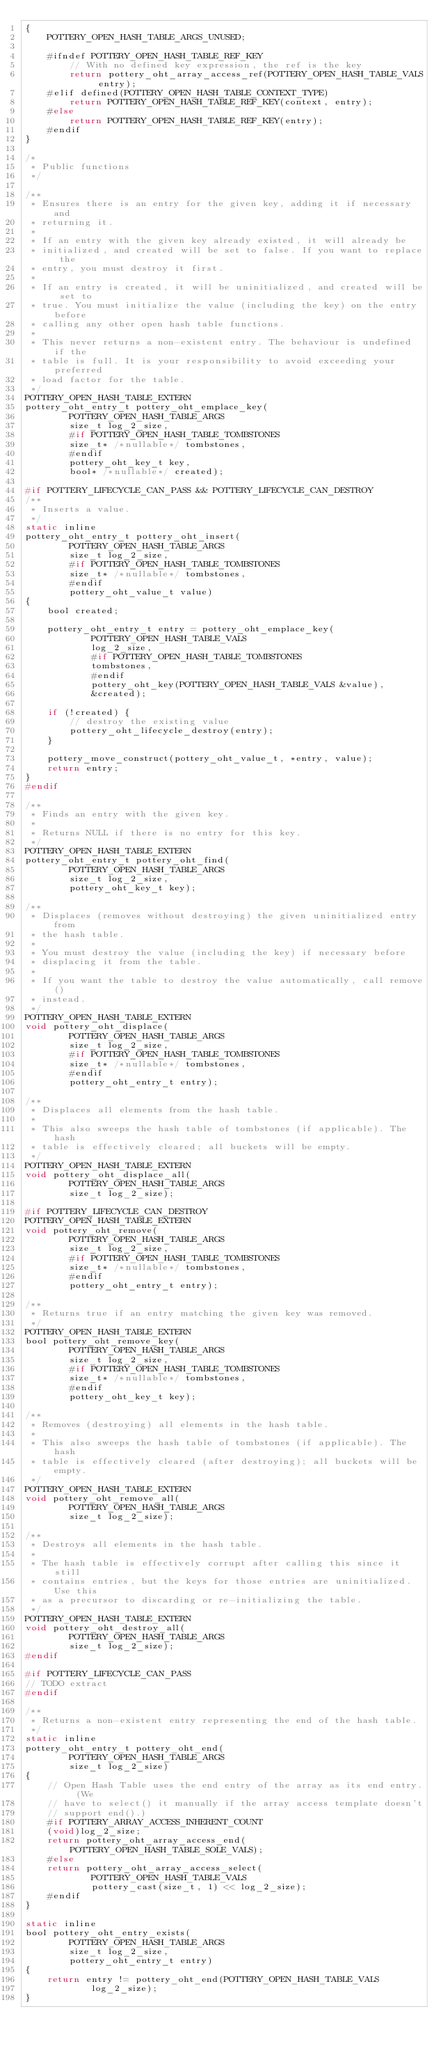Convert code to text. <code><loc_0><loc_0><loc_500><loc_500><_C_>{
    POTTERY_OPEN_HASH_TABLE_ARGS_UNUSED;

    #ifndef POTTERY_OPEN_HASH_TABLE_REF_KEY
        // With no defined key expression, the ref is the key
        return pottery_oht_array_access_ref(POTTERY_OPEN_HASH_TABLE_VALS entry);
    #elif defined(POTTERY_OPEN_HASH_TABLE_CONTEXT_TYPE)
        return POTTERY_OPEN_HASH_TABLE_REF_KEY(context, entry);
    #else
        return POTTERY_OPEN_HASH_TABLE_REF_KEY(entry);
    #endif
}

/*
 * Public functions
 */

/**
 * Ensures there is an entry for the given key, adding it if necessary and
 * returning it.
 *
 * If an entry with the given key already existed, it will already be
 * initialized, and created will be set to false. If you want to replace the
 * entry, you must destroy it first.
 *
 * If an entry is created, it will be uninitialized, and created will be set to
 * true. You must initialize the value (including the key) on the entry before
 * calling any other open hash table functions.
 *
 * This never returns a non-existent entry. The behaviour is undefined if the
 * table is full. It is your responsibility to avoid exceeding your preferred
 * load factor for the table.
 */
POTTERY_OPEN_HASH_TABLE_EXTERN
pottery_oht_entry_t pottery_oht_emplace_key(
        POTTERY_OPEN_HASH_TABLE_ARGS
        size_t log_2_size,
        #if POTTERY_OPEN_HASH_TABLE_TOMBSTONES
        size_t* /*nullable*/ tombstones,
        #endif
        pottery_oht_key_t key,
        bool* /*nullable*/ created);

#if POTTERY_LIFECYCLE_CAN_PASS && POTTERY_LIFECYCLE_CAN_DESTROY
/**
 * Inserts a value.
 */
static inline
pottery_oht_entry_t pottery_oht_insert(
        POTTERY_OPEN_HASH_TABLE_ARGS
        size_t log_2_size,
        #if POTTERY_OPEN_HASH_TABLE_TOMBSTONES
        size_t* /*nullable*/ tombstones,
        #endif
        pottery_oht_value_t value)
{
    bool created;

    pottery_oht_entry_t entry = pottery_oht_emplace_key(
            POTTERY_OPEN_HASH_TABLE_VALS
            log_2_size,
            #if POTTERY_OPEN_HASH_TABLE_TOMBSTONES
            tombstones,
            #endif
            pottery_oht_key(POTTERY_OPEN_HASH_TABLE_VALS &value),
            &created);

    if (!created) {
        // destroy the existing value
        pottery_oht_lifecycle_destroy(entry);
    }

    pottery_move_construct(pottery_oht_value_t, *entry, value);
    return entry;
}
#endif

/**
 * Finds an entry with the given key.
 *
 * Returns NULL if there is no entry for this key.
 */
POTTERY_OPEN_HASH_TABLE_EXTERN
pottery_oht_entry_t pottery_oht_find(
        POTTERY_OPEN_HASH_TABLE_ARGS
        size_t log_2_size,
        pottery_oht_key_t key);

/**
 * Displaces (removes without destroying) the given uninitialized entry from
 * the hash table.
 *
 * You must destroy the value (including the key) if necessary before
 * displacing it from the table.
 *
 * If you want the table to destroy the value automatically, call remove()
 * instead.
 */
POTTERY_OPEN_HASH_TABLE_EXTERN
void pottery_oht_displace(
        POTTERY_OPEN_HASH_TABLE_ARGS
        size_t log_2_size,
        #if POTTERY_OPEN_HASH_TABLE_TOMBSTONES
        size_t* /*nullable*/ tombstones,
        #endif
        pottery_oht_entry_t entry);

/**
 * Displaces all elements from the hash table.
 *
 * This also sweeps the hash table of tombstones (if applicable). The hash
 * table is effectively cleared; all buckets will be empty.
 */
POTTERY_OPEN_HASH_TABLE_EXTERN
void pottery_oht_displace_all(
        POTTERY_OPEN_HASH_TABLE_ARGS
        size_t log_2_size);

#if POTTERY_LIFECYCLE_CAN_DESTROY
POTTERY_OPEN_HASH_TABLE_EXTERN
void pottery_oht_remove(
        POTTERY_OPEN_HASH_TABLE_ARGS
        size_t log_2_size,
        #if POTTERY_OPEN_HASH_TABLE_TOMBSTONES
        size_t* /*nullable*/ tombstones,
        #endif
        pottery_oht_entry_t entry);

/**
 * Returns true if an entry matching the given key was removed.
 */
POTTERY_OPEN_HASH_TABLE_EXTERN
bool pottery_oht_remove_key(
        POTTERY_OPEN_HASH_TABLE_ARGS
        size_t log_2_size,
        #if POTTERY_OPEN_HASH_TABLE_TOMBSTONES
        size_t* /*nullable*/ tombstones,
        #endif
        pottery_oht_key_t key);

/**
 * Removes (destroying) all elements in the hash table.
 *
 * This also sweeps the hash table of tombstones (if applicable). The hash
 * table is effectively cleared (after destroying); all buckets will be empty.
 */
POTTERY_OPEN_HASH_TABLE_EXTERN
void pottery_oht_remove_all(
        POTTERY_OPEN_HASH_TABLE_ARGS
        size_t log_2_size);

/**
 * Destroys all elements in the hash table.
 *
 * The hash table is effectively corrupt after calling this since it still
 * contains entries, but the keys for those entries are uninitialized. Use this
 * as a precursor to discarding or re-initializing the table.
 */
POTTERY_OPEN_HASH_TABLE_EXTERN
void pottery_oht_destroy_all(
        POTTERY_OPEN_HASH_TABLE_ARGS
        size_t log_2_size);
#endif

#if POTTERY_LIFECYCLE_CAN_PASS
// TODO extract
#endif

/**
 * Returns a non-existent entry representing the end of the hash table.
 */
static inline
pottery_oht_entry_t pottery_oht_end(
        POTTERY_OPEN_HASH_TABLE_ARGS
        size_t log_2_size)
{
    // Open Hash Table uses the end entry of the array as its end entry. (We
    // have to select() it manually if the array access template doesn't
    // support end().)
    #if POTTERY_ARRAY_ACCESS_INHERENT_COUNT
    (void)log_2_size;
    return pottery_oht_array_access_end(POTTERY_OPEN_HASH_TABLE_SOLE_VALS);
    #else
    return pottery_oht_array_access_select(
            POTTERY_OPEN_HASH_TABLE_VALS
            pottery_cast(size_t, 1) << log_2_size);
    #endif
}

static inline
bool pottery_oht_entry_exists(
        POTTERY_OPEN_HASH_TABLE_ARGS
        size_t log_2_size,
        pottery_oht_entry_t entry)
{
    return entry != pottery_oht_end(POTTERY_OPEN_HASH_TABLE_VALS
            log_2_size);
}
</code> 